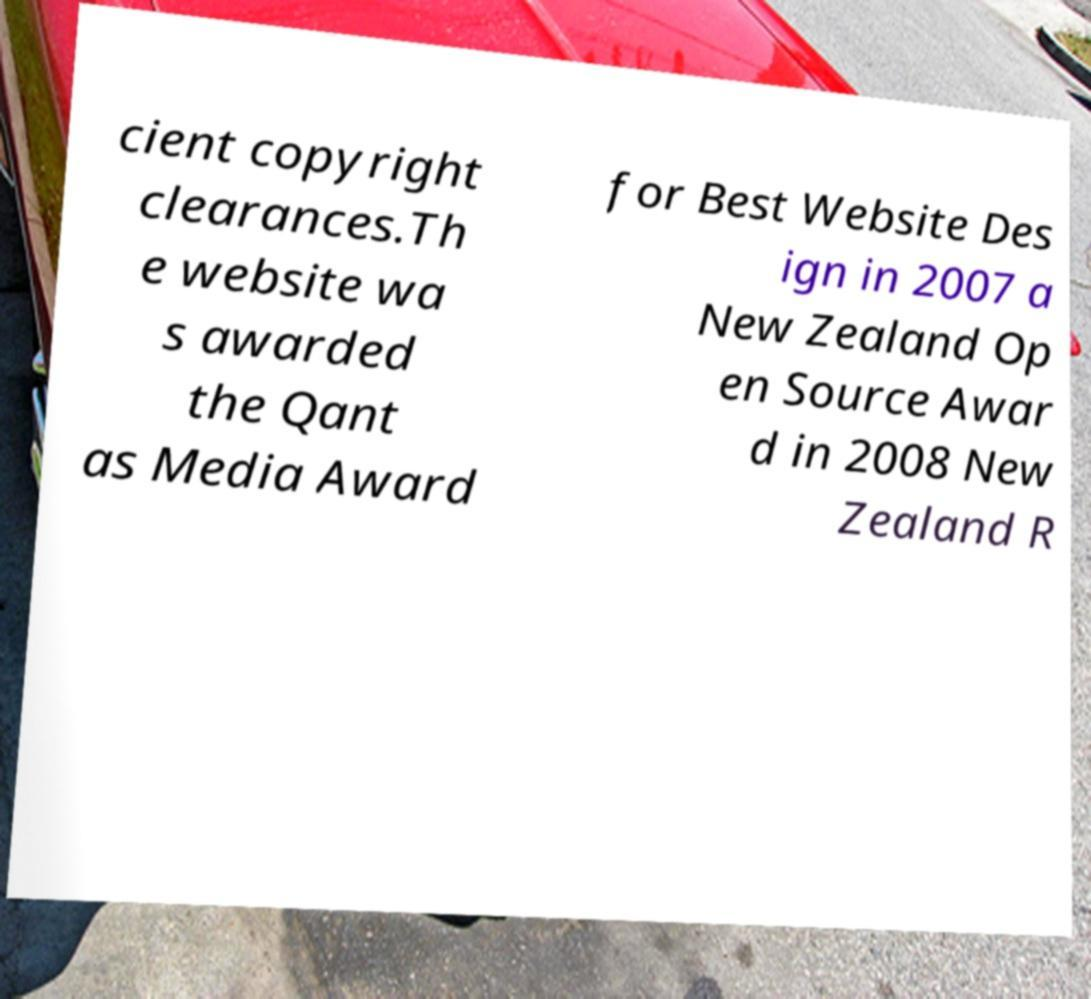Can you read and provide the text displayed in the image?This photo seems to have some interesting text. Can you extract and type it out for me? cient copyright clearances.Th e website wa s awarded the Qant as Media Award for Best Website Des ign in 2007 a New Zealand Op en Source Awar d in 2008 New Zealand R 